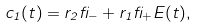Convert formula to latex. <formula><loc_0><loc_0><loc_500><loc_500>c _ { 1 } ( t ) = r _ { 2 } \beta _ { - } + r _ { 1 } \beta _ { + } E ( t ) ,</formula> 